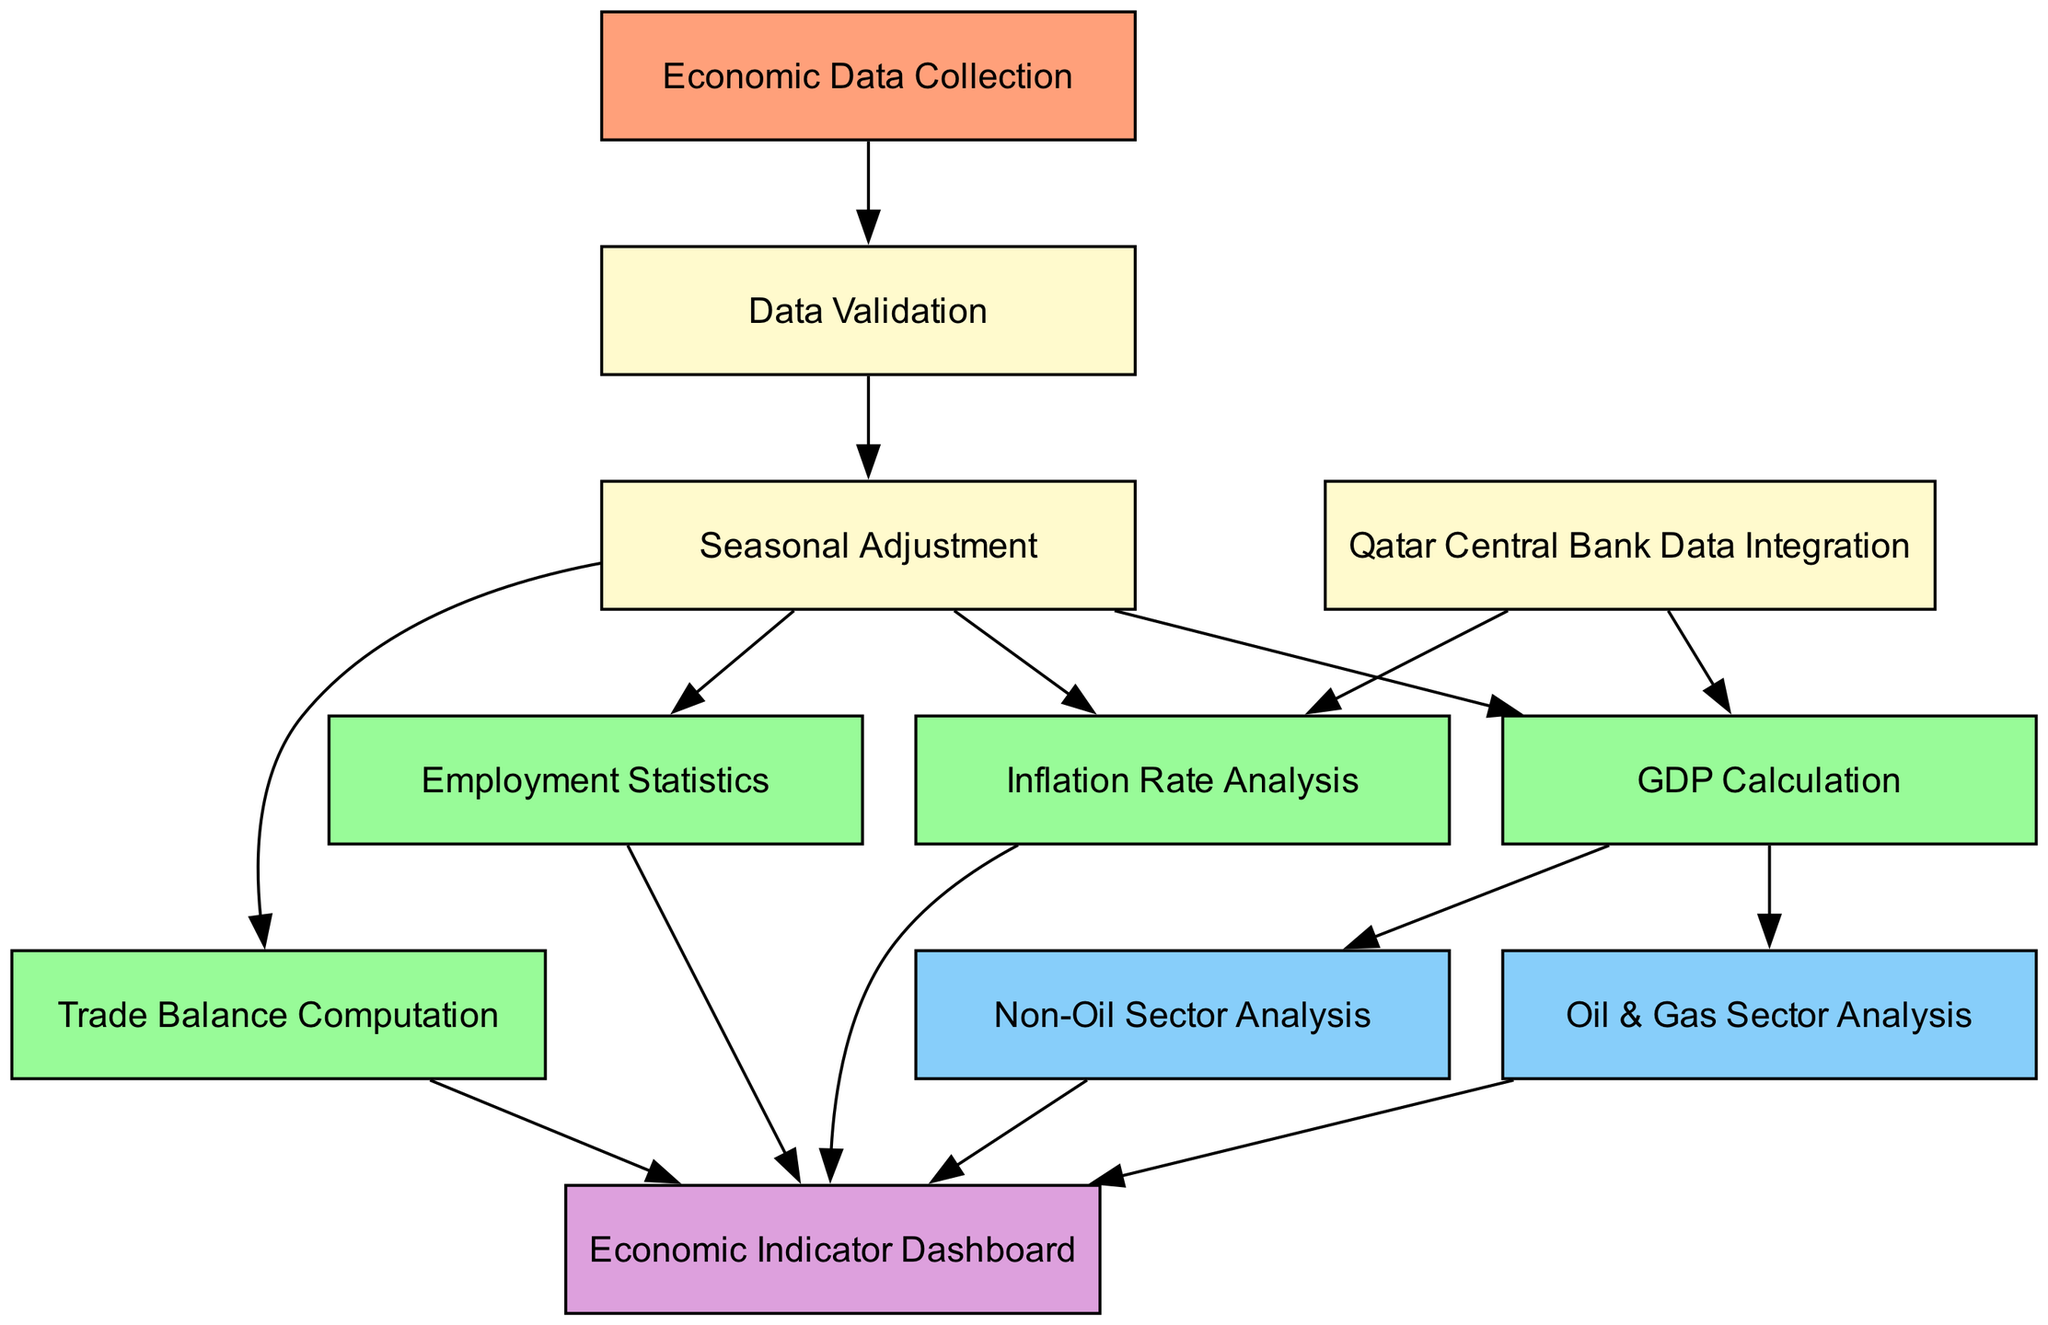What is the starting point of the pipeline? The starting point of the pipeline is indicated by the first node in the diagram, which is "Economic Data Collection." This node is marked as the initial step before any further actions take place.
Answer: Economic Data Collection How many nodes are there in total? To find the total number of nodes, we count the number of individual items listed within both the "nodes" key and the "start" and "end" keys. In this case, there are 10 nodes plus the start and end nodes, resulting in a total of 12 nodes.
Answer: 12 What color is the "GDP Calculation" node? The "GDP Calculation" node is colored green, as specified in the node style section of the diagram generation code for nodes related to GDP, inflation, employment statistics, and trade balance.
Answer: Green What is the last step of the pipeline? The last step of the pipeline is indicated by the "end" node in the diagram, which is the "Economic Indicator Dashboard." This node represents the final output after processing all previous data.
Answer: Economic Indicator Dashboard Which node connects directly from "Seasonal Adjustment" and "Qatar Central Bank Data Integration"? The node that connects directly from both "Seasonal Adjustment" and "Qatar Central Bank Data Integration" is "GDP Calculation." The diagram shows these connections explicitly, indicating the data flow from both sources into this computation node.
Answer: GDP Calculation How many edges are there in total? To determine the total number of edges, we count all the connections between nodes as defined in the "edges" section of the diagram. There are 14 edges connecting the various nodes throughout the pipeline.
Answer: 14 Which analysis area contributes to the "Economic Indicator Dashboard" from the "Seasonal Adjustment"? The analysis areas contributing to the "Economic Indicator Dashboard" from the "Seasonal Adjustment" node are "Inflation Rate Analysis," "Employment Statistics," and "Trade Balance Computation." All these nodes are directly linked to the dashboard from seasonal adjustments.
Answer: Inflation Rate Analysis, Employment Statistics, Trade Balance Computation What action follows "Data Validation"? The action that immediately follows "Data Validation" in the flow of the pipeline is "Seasonal Adjustment." This is a direct progression from validating the data to adjusting for seasonality in the data processing.
Answer: Seasonal Adjustment How do the "Oil & Gas Sector Analysis" and "Non-Oil Sector Analysis" interact with the overall pipeline? Both "Oil & Gas Sector Analysis" and "Non-Oil Sector Analysis" contribute to the final output represented by the "Economic Indicator Dashboard," meaning they aggregate specific sector insights which are visualized together in the dashboard.
Answer: They both connect to the Economic Indicator Dashboard 